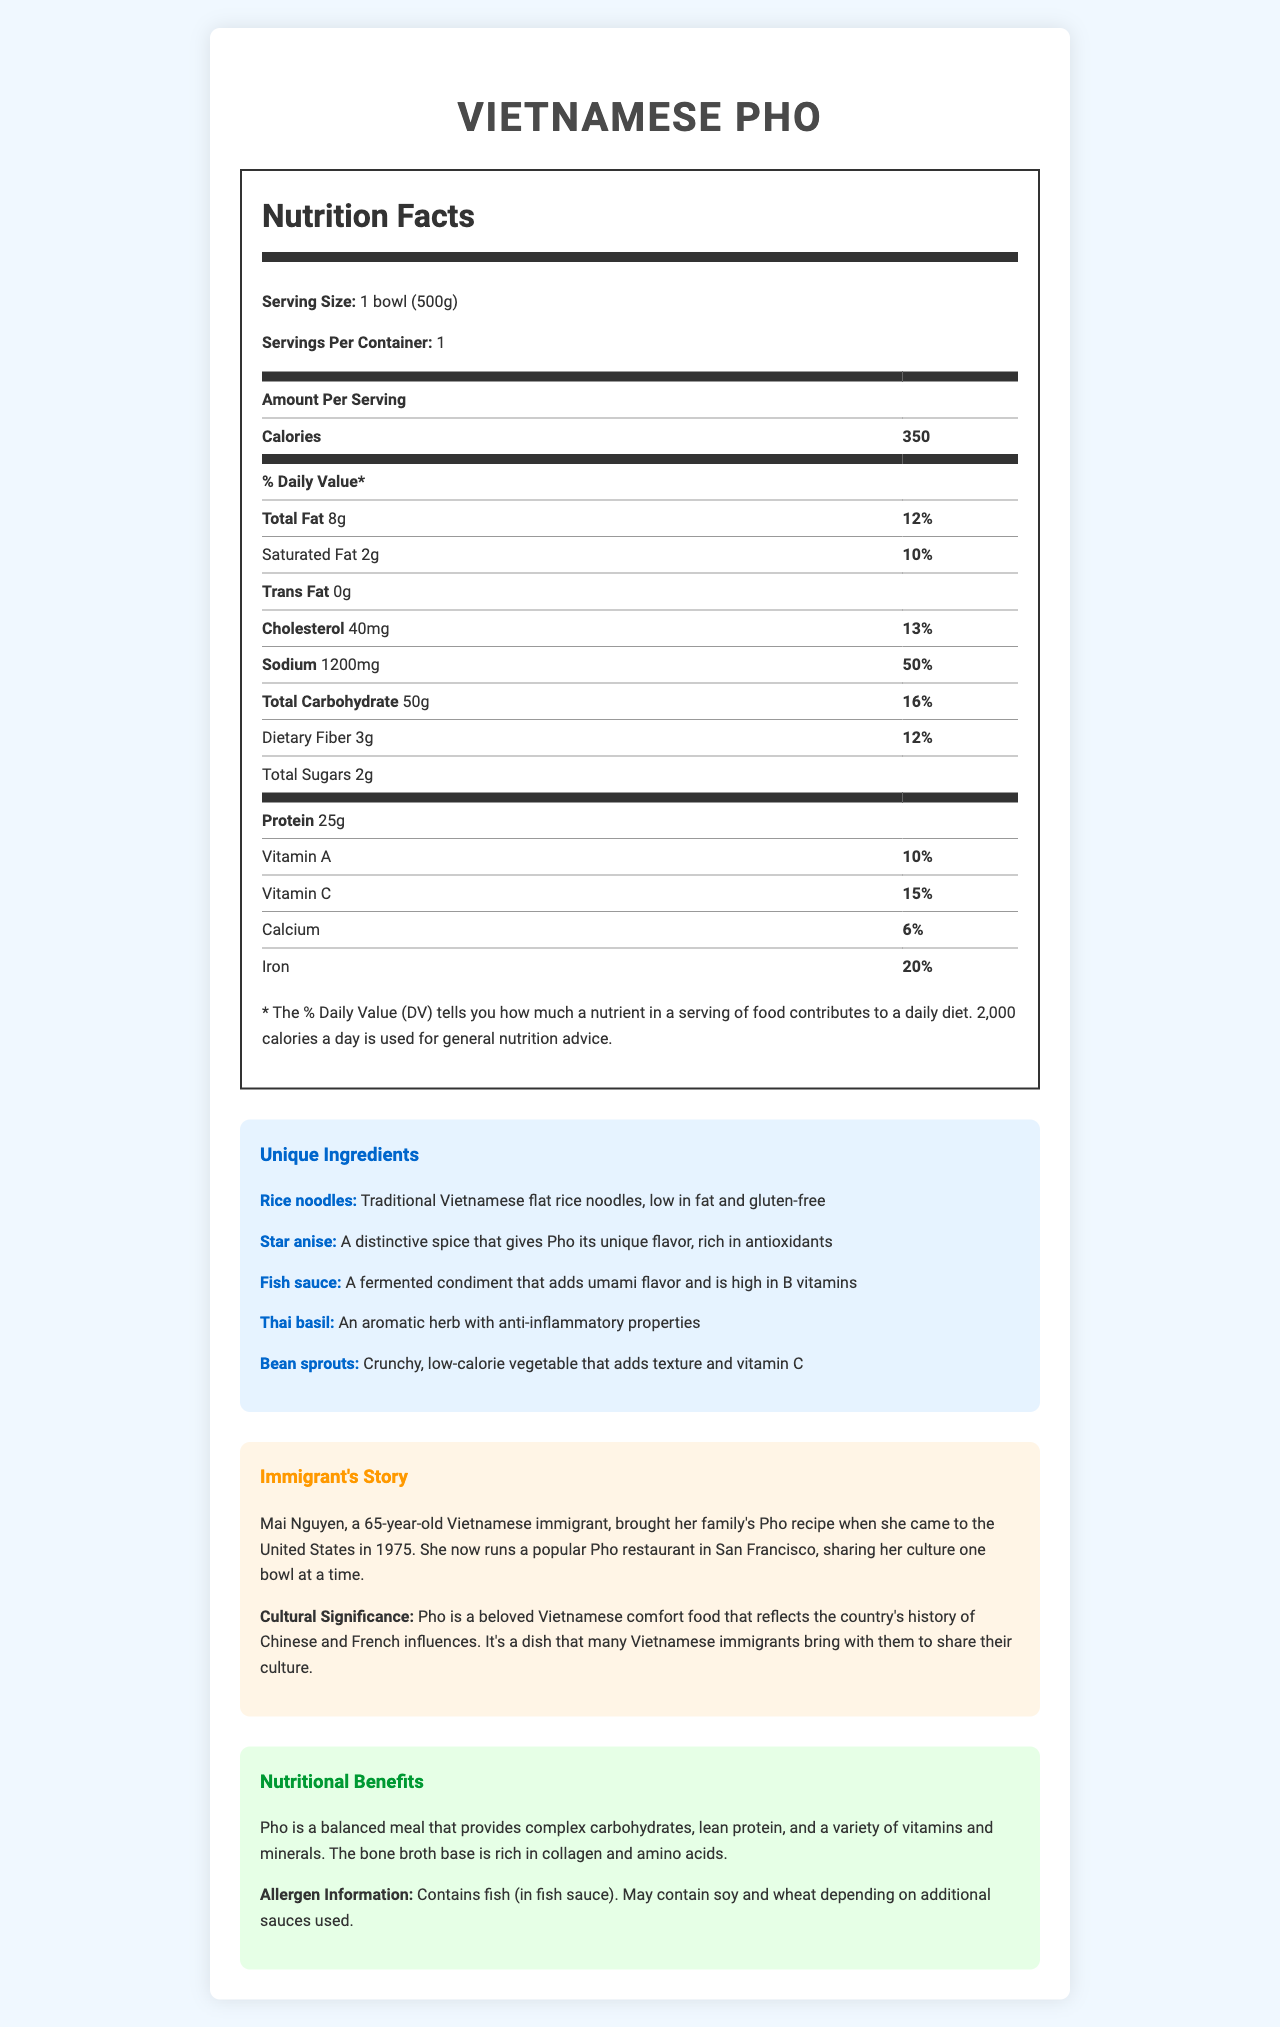how many calories does one bowl of Vietnamese Pho contain? The document states that one serving of Vietnamese Pho, which is one bowl (500g), contains 350 calories.
Answer: 350 calories what is the serving size for Vietnamese Pho? The Nutrition Facts label specifies that the serving size for Vietnamese Pho is 1 bowl (500g).
Answer: 1 bowl (500g) how much sodium is in one serving of Vietnamese Pho? The Nutrition Facts label indicates that one serving of Vietnamese Pho contains 1200 mg of sodium.
Answer: 1200 mg what percentage of the daily value of iron does one serving of Vietnamese Pho provide? The document specifies that one serving of Vietnamese Pho provides 20% of the daily value for iron.
Answer: 20% what are traditional Vietnamese flat rice noodles like? The description in the unique ingredients section states that traditional Vietnamese flat rice noodles are low in fat and gluten-free.
Answer: Low in fat and gluten-free which of the following is a distinctive spice used in Vietnamese Pho? A. Cinnamon B. Star anise C. Cloves The unique ingredients section describes star anise as a distinctive spice that gives Pho its unique flavor.
Answer: B. Star anise what is the main ingredient that adds umami flavor to Pho? A. Star anise B. Thai basil C. Fish sauce The description in the unique ingredients section states that fish sauce is a fermented condiment that adds umami flavor.
Answer: C. Fish sauce does Vietnamese Pho contain any trans fat? The Nutrition Facts label shows that the amount of trans fat in one serving of Vietnamese Pho is 0 grams.
Answer: No describe the main idea of the document. The document focuses on presenting detailed nutritional information about Vietnamese Pho, highlighting its unique ingredients and cultural importance, along with an immigrant's story about sharing her family's Pho recipe in the United States.
Answer: The document provides a detailed Nutrition Facts label for Vietnamese Pho, including serving size, calorie and nutrient content, unique ingredients, cultural significance, and a story about an immigrant who brought the dish to the United States. what is Mai Nguyen's story related to Vietnamese Pho? The story section of the document tells that Mai Nguyen brought her family's Pho recipe when she came to the United States in 1975 and now runs a popular Pho restaurant in San Francisco.
Answer: Mai Nguyen, a 65-year-old Vietnamese immigrant, brought her family's Pho recipe to the United States in 1975 and now runs a popular Pho restaurant in San Francisco. how many grams of dietary fiber are in one serving of Vietnamese Pho? The Nutrition Facts label specifies that one serving of Vietnamese Pho contains 3 grams of dietary fiber.
Answer: 3 grams can you determine the exact amount of Vitamin B in Vietnamese Pho from the document? The document does not provide specific information about the amount of Vitamin B in Vietnamese Pho.
Answer: Not enough information what is the cultural significance of Pho according to the document? The cultural significance section in the document explains that Pho reflects Vietnam's history of Chinese and French influences and is a beloved comfort food.
Answer: Pho reflects Vietnam's history of Chinese and French influences and is a beloved comfort food that many Vietnamese immigrants share. what allergen does Vietnamese Pho contain, according to the document? The allergen information section states that Vietnamese Pho contains fish (in fish sauce).
Answer: Fish (in fish sauce) what is the protein content in one serving of Vietnamese Pho? The Nutrition Facts label states that one serving of Vietnamese Pho contains 25 grams of protein.
Answer: 25 grams 